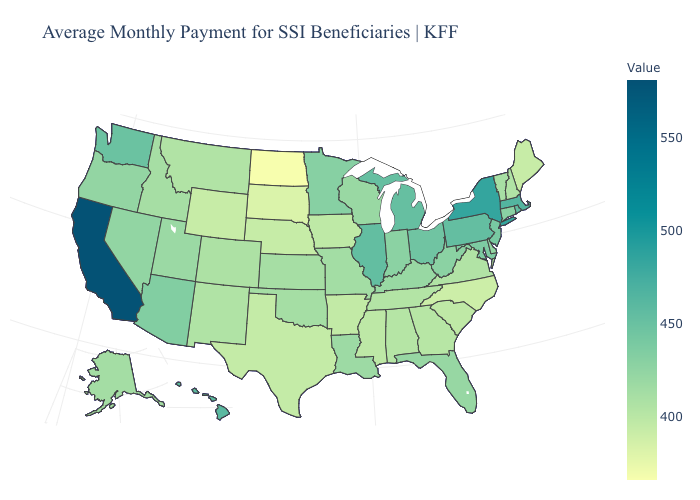Among the states that border Ohio , which have the lowest value?
Short answer required. Kentucky. Does the map have missing data?
Keep it brief. No. Does California have the highest value in the USA?
Write a very short answer. Yes. 